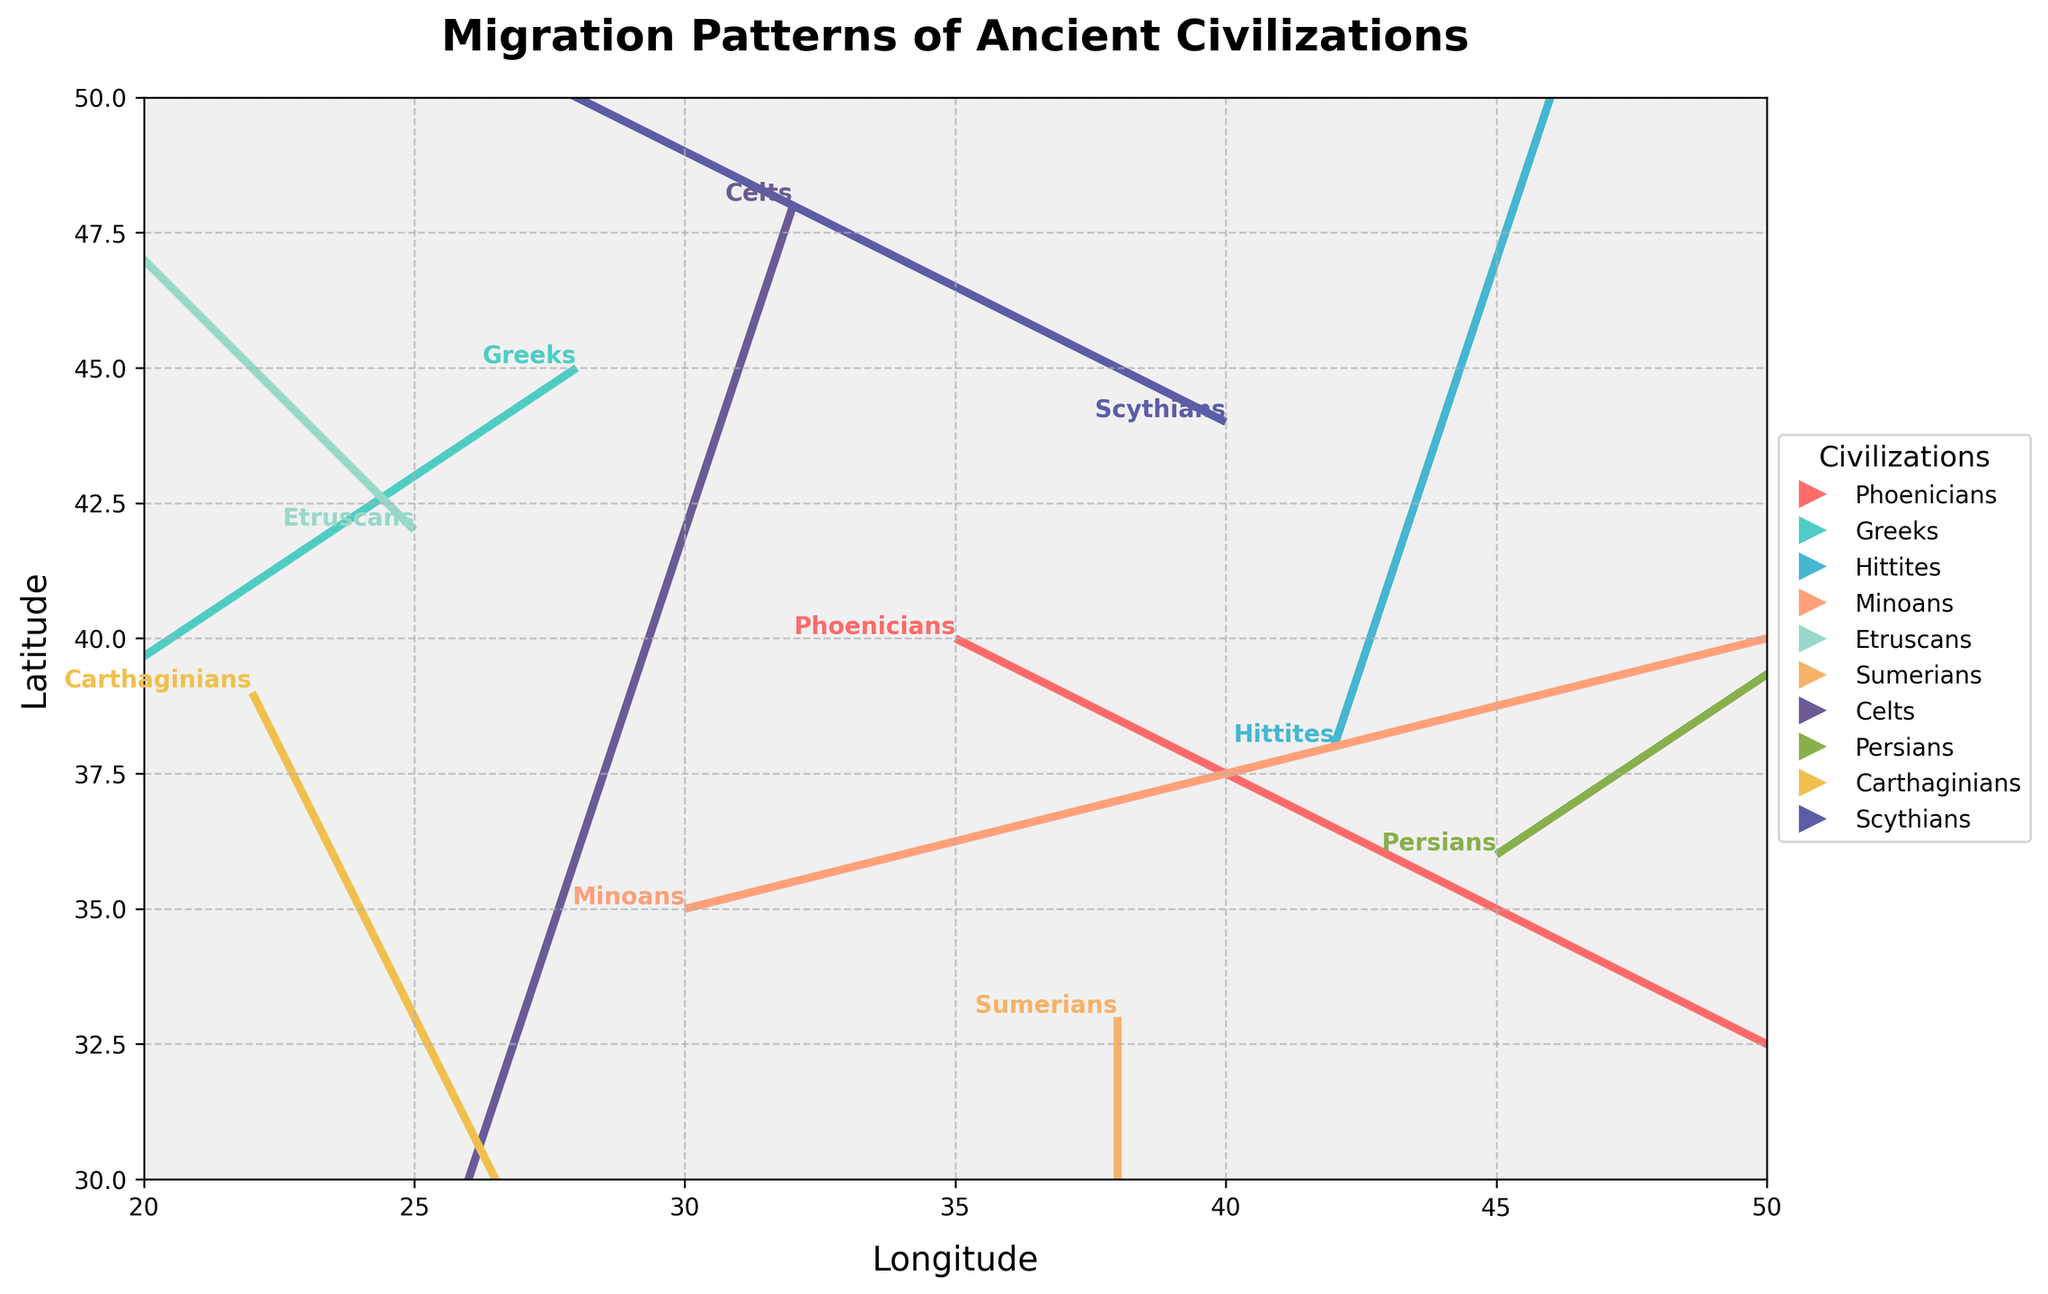What is the title of the plot? The title is located at the top of the plot. It states, "Migration Patterns of Ancient Civilizations".
Answer: Migration Patterns of Ancient Civilizations Which civilization has the largest movement in longitude? By examining the origin and direction of the vectors, the Minoans have the largest movement in longitude by moving 4 units to the right.
Answer: Minoans Where do the Greeks start, and which direction do they migrate towards? The Greeks start at (28, 45). They migrate left by 3 units and down by 2 units, as indicated by their vector.
Answer: Start at (28, 45); move left and down What is the migration direction and magnitude for the Sumerians? The Sumerians start at (38, 33) and their vector points directly downward with a magnitude of 4 units.
Answer: Downward, 4 units Which civilizations' migration directions are opposite to each other? The Greeks move left and down, while the Etruscans move left and up. These directions are opposite in the vertical component of their movements. The Persians move right and up, opposite to the Carthaginians, who move right and down.
Answer: Greeks and Etruscans, Persians and Carthaginians What is the aspect ratio of the plot? The aspect ratio is set to be equal to maintain the scale of longitudes and latitudes. It ensures that the proportions of the movement directions are accurate, reflecting equal distances on both axes.
Answer: Equal aspect ratio Compare the movements of the Phoenicians and the Carthaginians in terms of direction and distance. The Phoenicians move right and slightly down by a vector of (2, -1). The Carthaginians move right and down by a vector of (1, -2). Phoenicians have a higher horizontal movement, while Carthaginians have a larger vertical movement.
Answer: Phoenicians: right and slightly down, Carthaginians: right and down Which civilizations are migrating within the plot's grid boundaries (20, 50) for both x and y axes? All civilizations start within the plot's grid boundaries based on their initial positions (x, y) and their movement vectors.
Answer: All civilizations How does the migration of the Scythians compare to the Minoans in terms of direction? The Scythians move left and slightly up as indicated by their vector (-2, 1), whereas the Minoans move right and slightly up as indicated by their vector (4, 1). They differ in horizontal direction but share a similar vertical component.
Answer: Scythians: left and slightly up, Minoans: right and slightly up What are the x and y grid limits of the plot? The limits for the x-axis range from 20 to 50, and the limits for the y-axis range from 30 to 50 as set in the plot.
Answer: x: 20-50, y: 30-50 